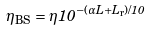Convert formula to latex. <formula><loc_0><loc_0><loc_500><loc_500>\eta _ { \text {BS} } = \eta 1 0 ^ { - ( \alpha L + L _ { \text {r} } ) / 1 0 }</formula> 